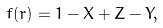Convert formula to latex. <formula><loc_0><loc_0><loc_500><loc_500>f ( r ) = 1 - X + Z - Y ,</formula> 